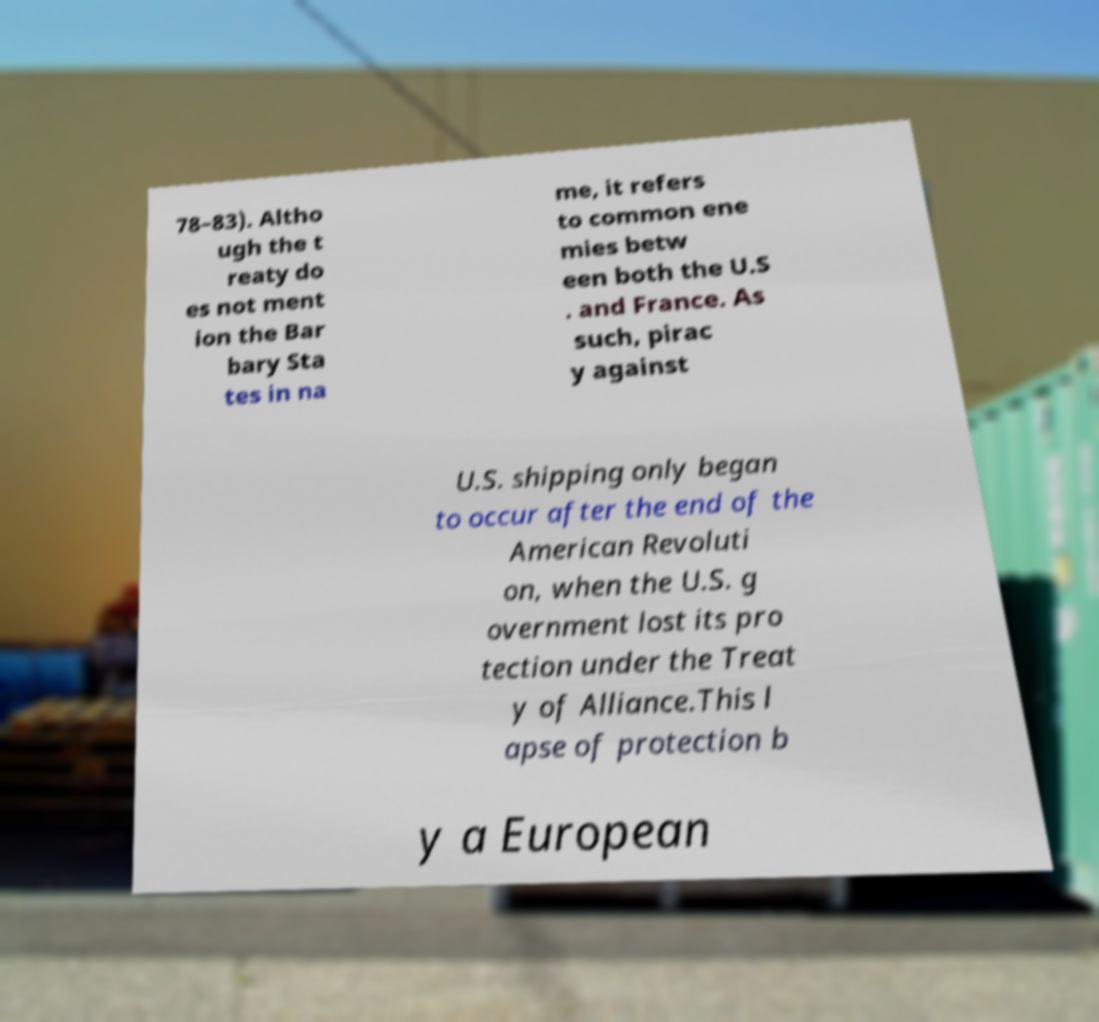Could you assist in decoding the text presented in this image and type it out clearly? 78–83). Altho ugh the t reaty do es not ment ion the Bar bary Sta tes in na me, it refers to common ene mies betw een both the U.S . and France. As such, pirac y against U.S. shipping only began to occur after the end of the American Revoluti on, when the U.S. g overnment lost its pro tection under the Treat y of Alliance.This l apse of protection b y a European 